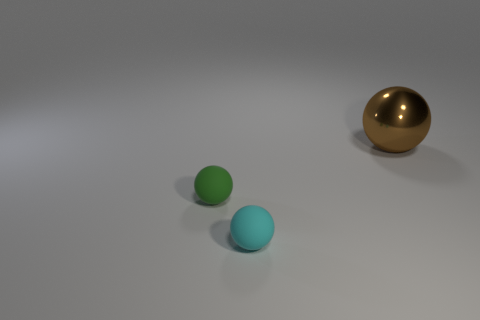Add 2 big gray metal cylinders. How many objects exist? 5 Subtract all cyan balls. How many balls are left? 2 Subtract all tiny cyan balls. How many balls are left? 2 Subtract 1 spheres. How many spheres are left? 2 Add 2 small blocks. How many small blocks exist? 2 Subtract 0 red cubes. How many objects are left? 3 Subtract all gray spheres. Subtract all blue cylinders. How many spheres are left? 3 Subtract all blue cubes. How many green balls are left? 1 Subtract all cylinders. Subtract all large spheres. How many objects are left? 2 Add 2 matte balls. How many matte balls are left? 4 